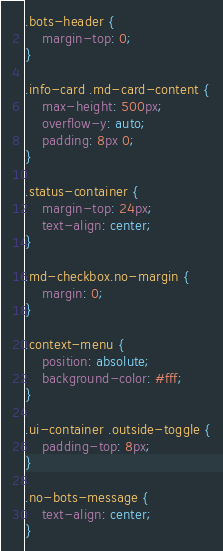Convert code to text. <code><loc_0><loc_0><loc_500><loc_500><_CSS_>.bots-header {
    margin-top: 0;
}

.info-card .md-card-content {
    max-height: 500px;
    overflow-y: auto;
    padding: 8px 0;
}

.status-container {
    margin-top: 24px;
    text-align: center;
}

.md-checkbox.no-margin {
    margin: 0;
}

.context-menu {
    position: absolute;
    background-color: #fff;
}

.ui-container .outside-toggle {
    padding-top: 8px;
}

.no-bots-message {
    text-align: center;
}
</code> 